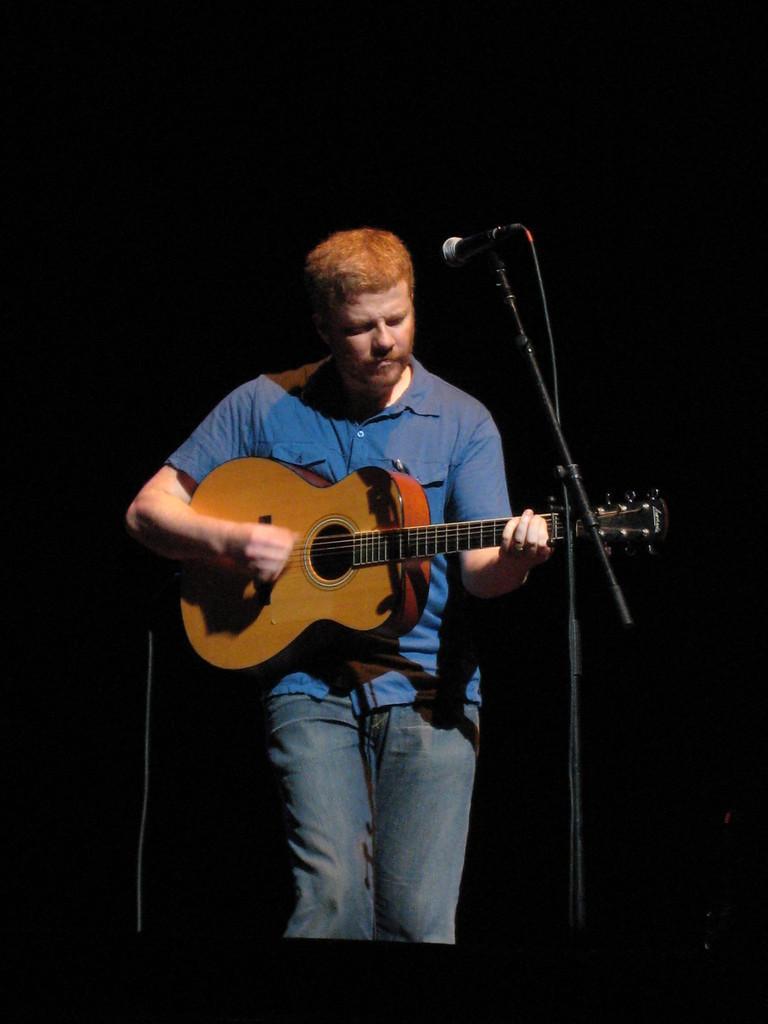How would you summarize this image in a sentence or two? In this picture we can see a man who is playing guitar and this is mike. 